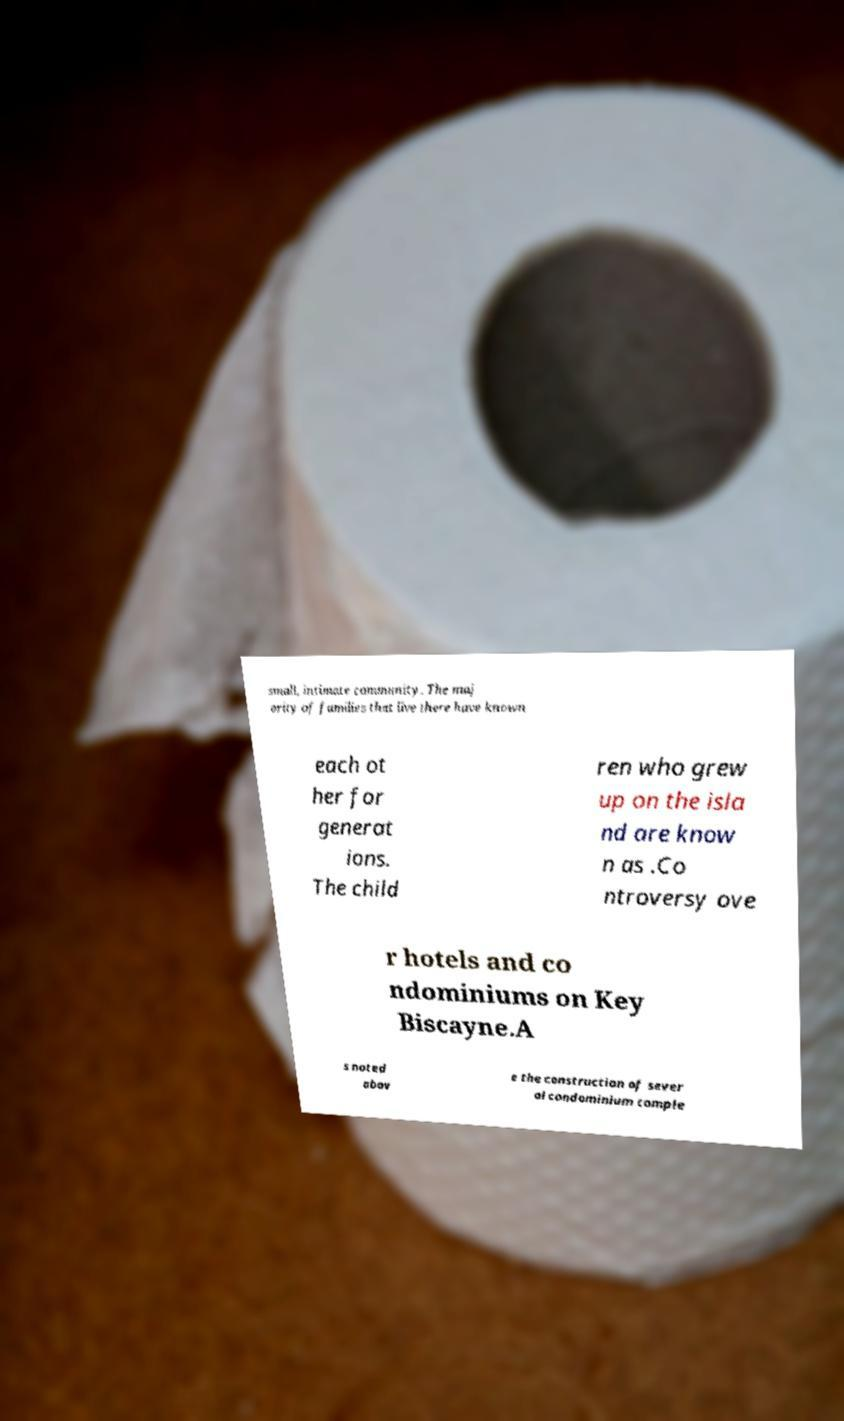Can you accurately transcribe the text from the provided image for me? small, intimate community. The maj ority of families that live there have known each ot her for generat ions. The child ren who grew up on the isla nd are know n as .Co ntroversy ove r hotels and co ndominiums on Key Biscayne.A s noted abov e the construction of sever al condominium comple 